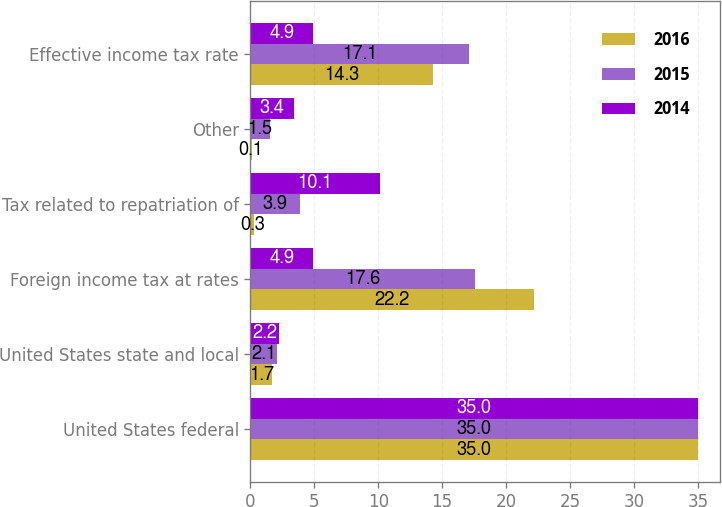Convert chart. <chart><loc_0><loc_0><loc_500><loc_500><stacked_bar_chart><ecel><fcel>United States federal<fcel>United States state and local<fcel>Foreign income tax at rates<fcel>Tax related to repatriation of<fcel>Other<fcel>Effective income tax rate<nl><fcel>2016<fcel>35<fcel>1.7<fcel>22.2<fcel>0.3<fcel>0.1<fcel>14.3<nl><fcel>2015<fcel>35<fcel>2.1<fcel>17.6<fcel>3.9<fcel>1.5<fcel>17.1<nl><fcel>2014<fcel>35<fcel>2.2<fcel>4.9<fcel>10.1<fcel>3.4<fcel>4.9<nl></chart> 